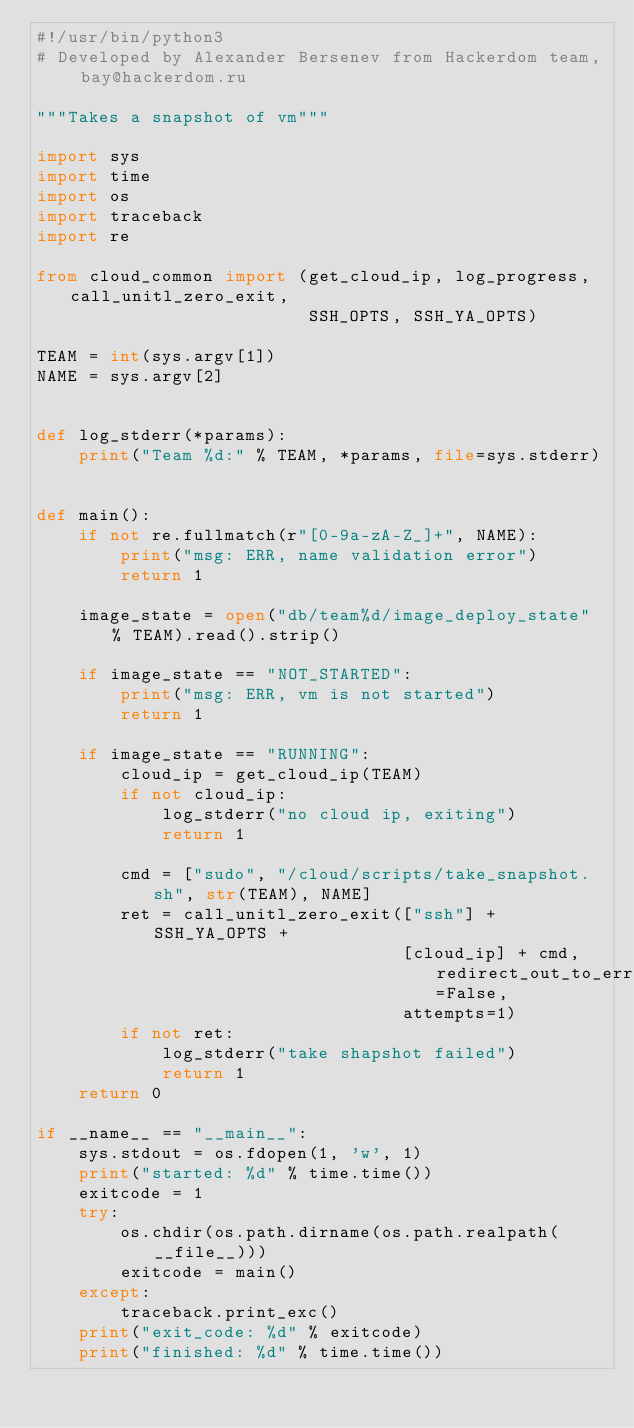<code> <loc_0><loc_0><loc_500><loc_500><_Python_>#!/usr/bin/python3
# Developed by Alexander Bersenev from Hackerdom team, bay@hackerdom.ru

"""Takes a snapshot of vm"""

import sys
import time
import os
import traceback
import re

from cloud_common import (get_cloud_ip, log_progress, call_unitl_zero_exit,
                          SSH_OPTS, SSH_YA_OPTS)

TEAM = int(sys.argv[1])
NAME = sys.argv[2]


def log_stderr(*params):
    print("Team %d:" % TEAM, *params, file=sys.stderr)


def main():
    if not re.fullmatch(r"[0-9a-zA-Z_]+", NAME):
        print("msg: ERR, name validation error")
        return 1

    image_state = open("db/team%d/image_deploy_state" % TEAM).read().strip()

    if image_state == "NOT_STARTED":
        print("msg: ERR, vm is not started")
        return 1

    if image_state == "RUNNING":
        cloud_ip = get_cloud_ip(TEAM)
        if not cloud_ip:
            log_stderr("no cloud ip, exiting")
            return 1

        cmd = ["sudo", "/cloud/scripts/take_snapshot.sh", str(TEAM), NAME]
        ret = call_unitl_zero_exit(["ssh"] + SSH_YA_OPTS +
                                   [cloud_ip] + cmd, redirect_out_to_err=False, 
                                   attempts=1)
        if not ret:
            log_stderr("take shapshot failed")
            return 1
    return 0

if __name__ == "__main__":
    sys.stdout = os.fdopen(1, 'w', 1)
    print("started: %d" % time.time())
    exitcode = 1
    try:
        os.chdir(os.path.dirname(os.path.realpath(__file__)))
        exitcode = main()
    except:
        traceback.print_exc()
    print("exit_code: %d" % exitcode)
    print("finished: %d" % time.time())
</code> 